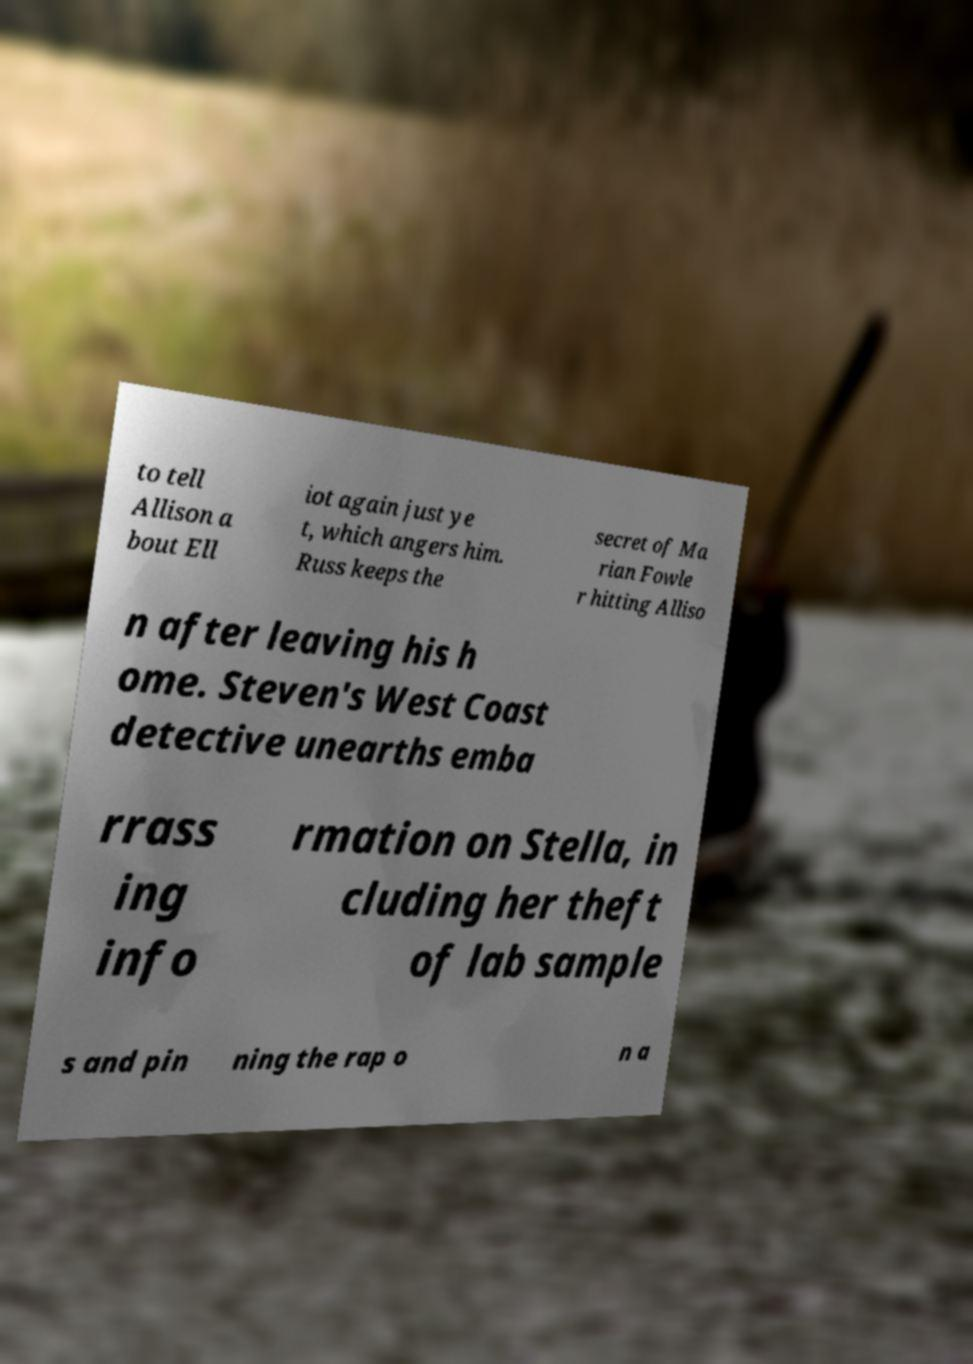There's text embedded in this image that I need extracted. Can you transcribe it verbatim? to tell Allison a bout Ell iot again just ye t, which angers him. Russ keeps the secret of Ma rian Fowle r hitting Alliso n after leaving his h ome. Steven's West Coast detective unearths emba rrass ing info rmation on Stella, in cluding her theft of lab sample s and pin ning the rap o n a 